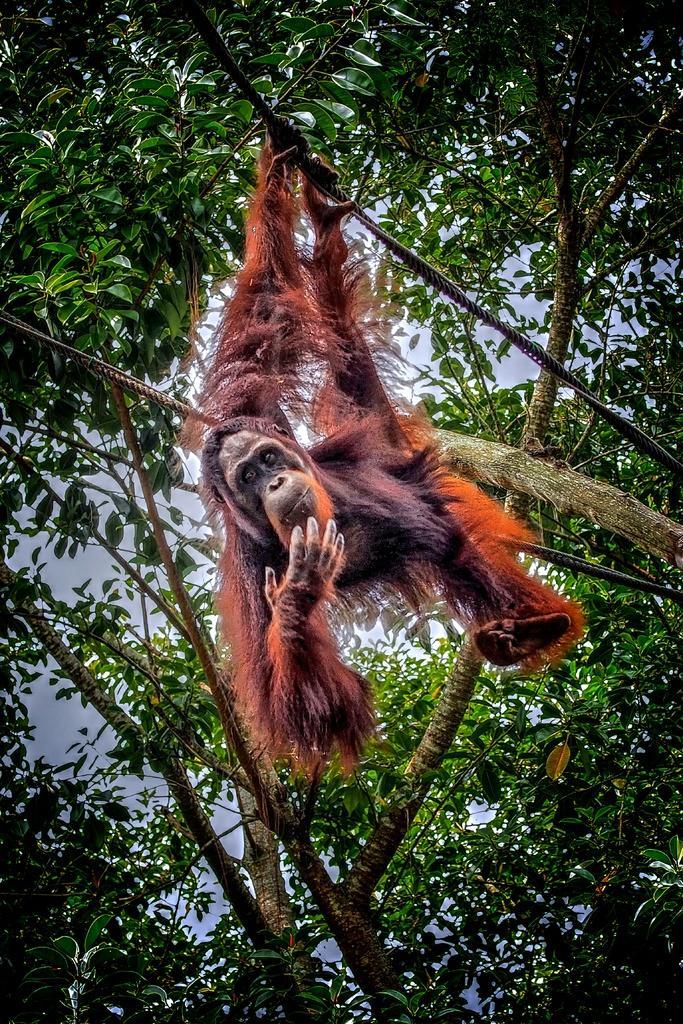In one or two sentences, can you explain what this image depicts? In this image we can see an orangutan is hanging from the tree branch. In the background, we can see trees and the sky. 